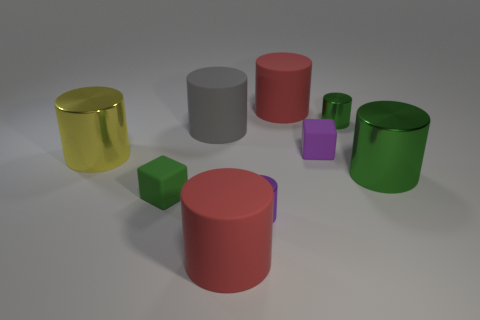Subtract all red cylinders. How many cylinders are left? 5 Subtract all red cylinders. How many cylinders are left? 5 Subtract all red cylinders. Subtract all brown spheres. How many cylinders are left? 5 Add 1 yellow metallic blocks. How many objects exist? 10 Subtract all cubes. How many objects are left? 7 Add 8 green cylinders. How many green cylinders exist? 10 Subtract 1 purple cylinders. How many objects are left? 8 Subtract all purple rubber blocks. Subtract all big yellow metal cylinders. How many objects are left? 7 Add 6 small blocks. How many small blocks are left? 8 